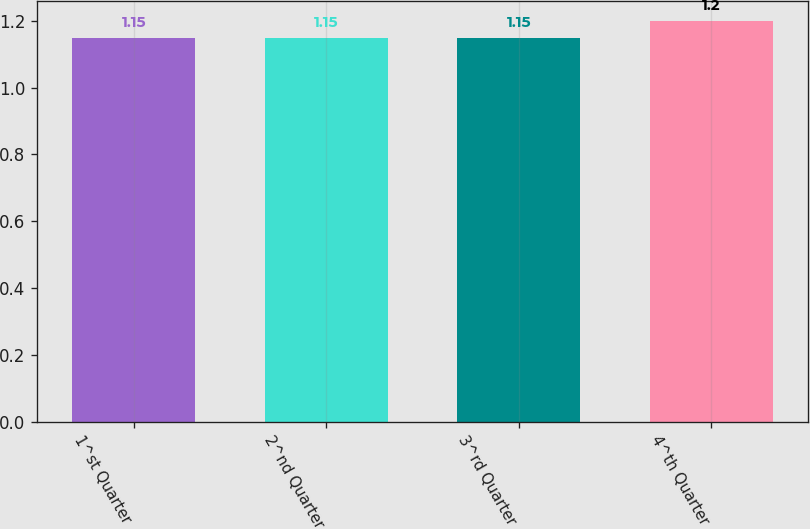<chart> <loc_0><loc_0><loc_500><loc_500><bar_chart><fcel>1^st Quarter<fcel>2^nd Quarter<fcel>3^rd Quarter<fcel>4^th Quarter<nl><fcel>1.15<fcel>1.15<fcel>1.15<fcel>1.2<nl></chart> 